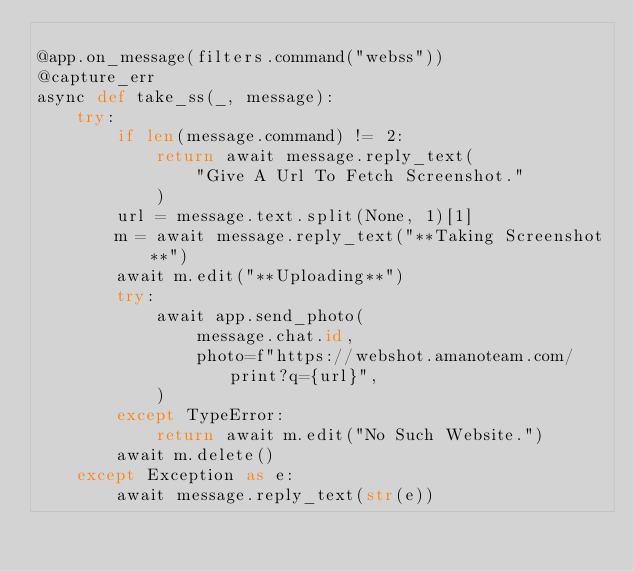Convert code to text. <code><loc_0><loc_0><loc_500><loc_500><_Python_>
@app.on_message(filters.command("webss"))
@capture_err
async def take_ss(_, message):
    try:
        if len(message.command) != 2:
            return await message.reply_text(
                "Give A Url To Fetch Screenshot."
            )
        url = message.text.split(None, 1)[1]
        m = await message.reply_text("**Taking Screenshot**")
        await m.edit("**Uploading**")
        try:
            await app.send_photo(
                message.chat.id,
                photo=f"https://webshot.amanoteam.com/print?q={url}",
            )
        except TypeError:
            return await m.edit("No Such Website.")
        await m.delete()
    except Exception as e:
        await message.reply_text(str(e))
</code> 